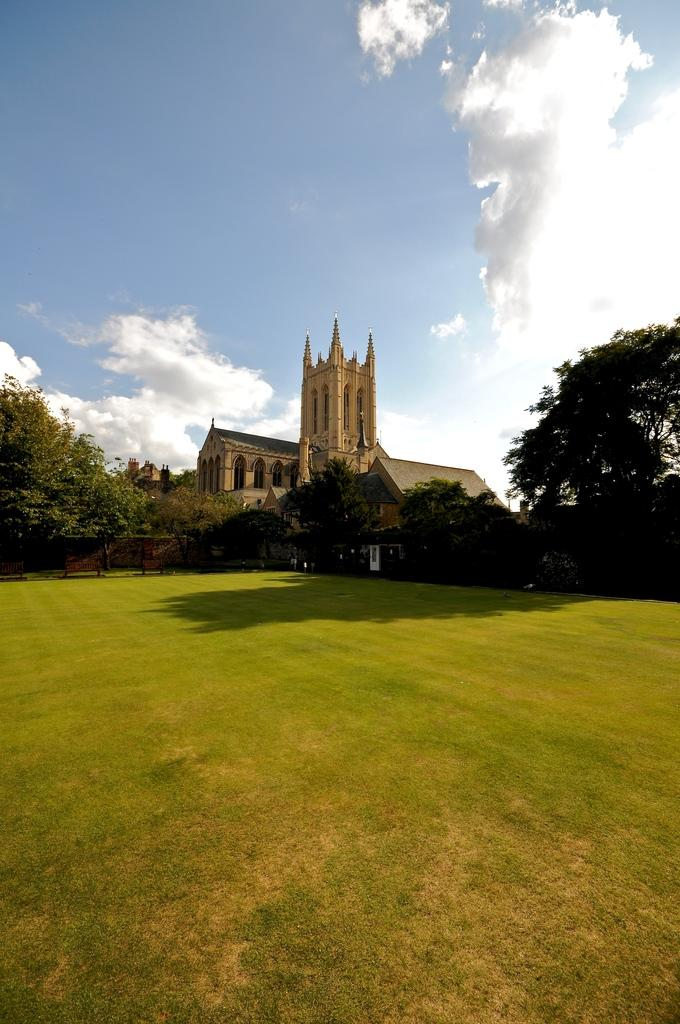What can be seen in the sky in the image? The sky is visible in the image, and there are clouds present. What type of vegetation is visible in the image? Trees and grass are visible in the image. What type of structure is present in the image? There is at least one building in the image. What is used to separate areas in the image? There is a fence in the image. What type of office can be seen in the image? There is no office present in the image. What type of border is visible in the image? There is no border present in the image. 